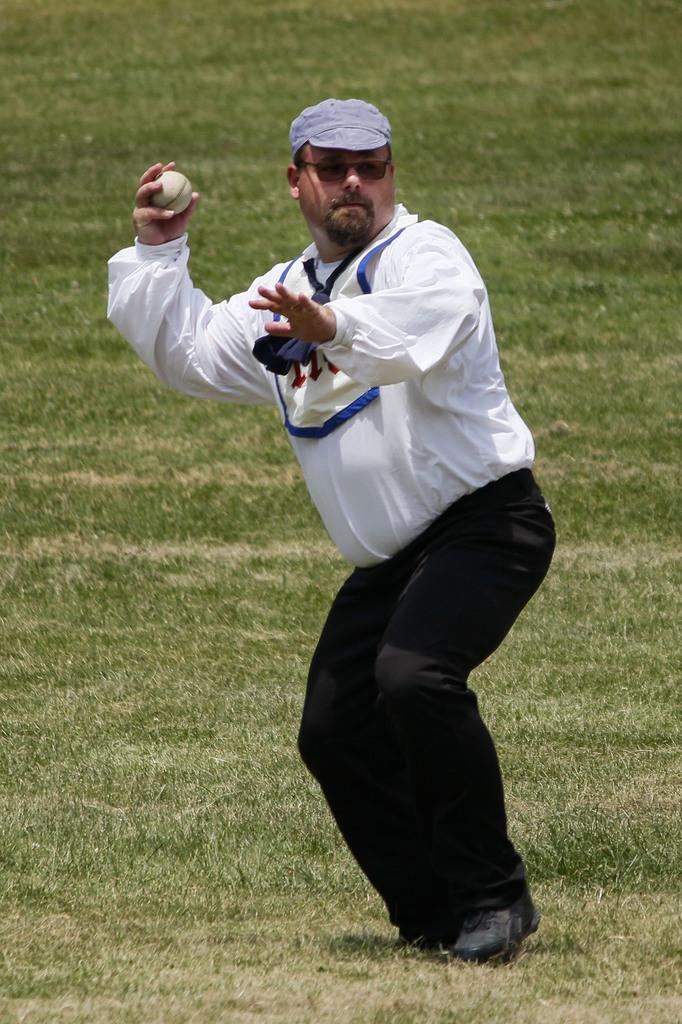What is the man in the image doing? The man is standing on the ground in the image. What is the man holding in the image? The man is holding a ball. What type of surface is the man standing on? There is grass visible in the image, so the man is standing on grass. What type of toothpaste is the man using in the image? There is no toothpaste present in the image; the man is holding a ball and standing on grass. How many deer can be seen in the image? There are no deer present in the image; it only features a man standing on grass and holding a ball. 